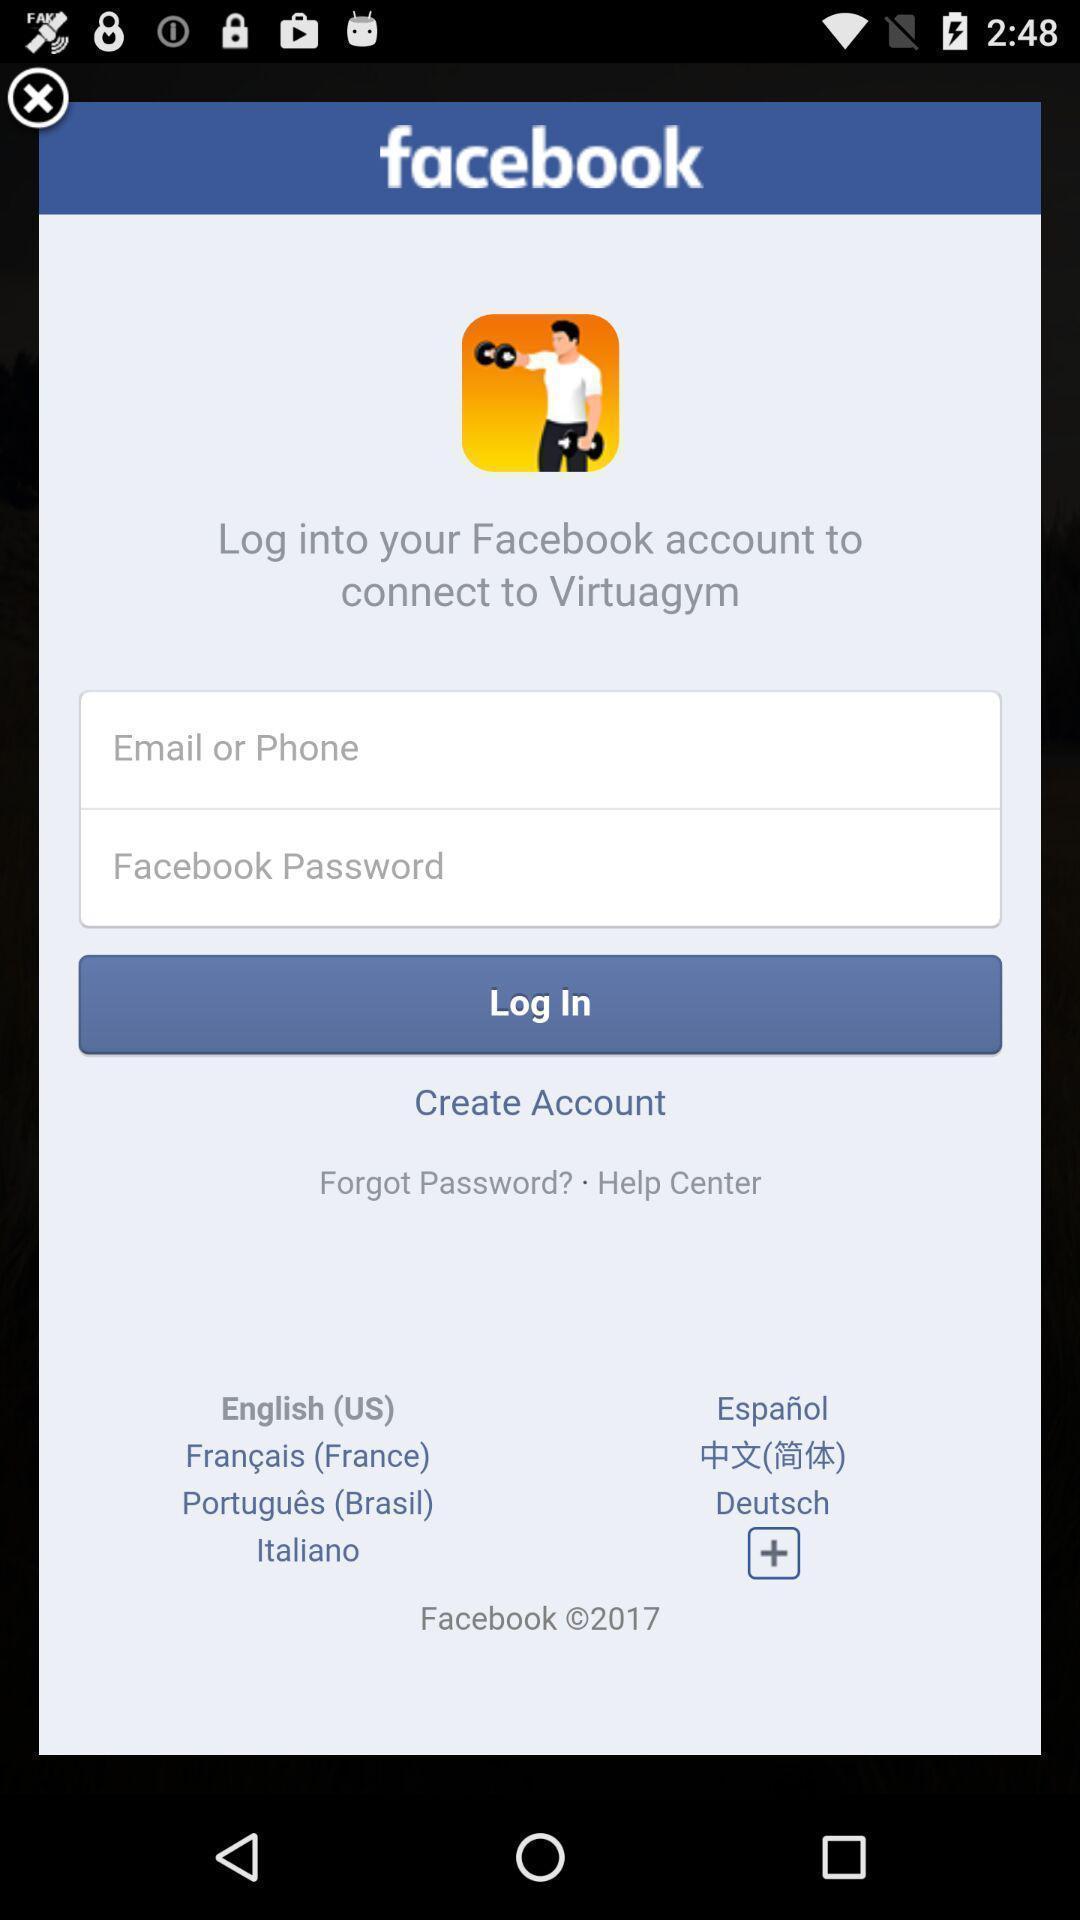Explain the elements present in this screenshot. Page showing login page. 